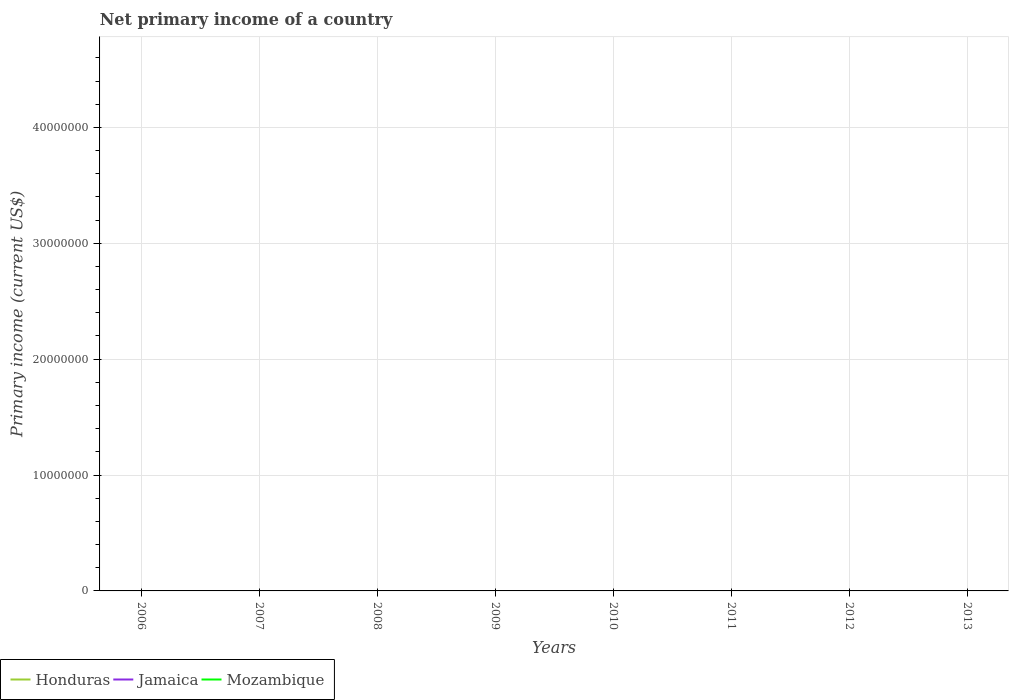Does the line corresponding to Honduras intersect with the line corresponding to Mozambique?
Provide a succinct answer. Yes. Across all years, what is the maximum primary income in Jamaica?
Your response must be concise. 0. What is the difference between the highest and the lowest primary income in Jamaica?
Ensure brevity in your answer.  0. Is the primary income in Mozambique strictly greater than the primary income in Jamaica over the years?
Ensure brevity in your answer.  No. How many legend labels are there?
Offer a very short reply. 3. How are the legend labels stacked?
Ensure brevity in your answer.  Horizontal. What is the title of the graph?
Keep it short and to the point. Net primary income of a country. Does "Uruguay" appear as one of the legend labels in the graph?
Offer a very short reply. No. What is the label or title of the X-axis?
Offer a terse response. Years. What is the label or title of the Y-axis?
Ensure brevity in your answer.  Primary income (current US$). What is the Primary income (current US$) of Jamaica in 2006?
Keep it short and to the point. 0. What is the Primary income (current US$) of Honduras in 2008?
Give a very brief answer. 0. What is the Primary income (current US$) of Jamaica in 2008?
Make the answer very short. 0. What is the Primary income (current US$) of Honduras in 2010?
Make the answer very short. 0. What is the Primary income (current US$) of Honduras in 2011?
Your answer should be compact. 0. What is the Primary income (current US$) of Honduras in 2012?
Give a very brief answer. 0. What is the Primary income (current US$) of Mozambique in 2012?
Your answer should be compact. 0. What is the Primary income (current US$) of Mozambique in 2013?
Ensure brevity in your answer.  0. What is the total Primary income (current US$) in Honduras in the graph?
Ensure brevity in your answer.  0. What is the average Primary income (current US$) of Honduras per year?
Make the answer very short. 0. What is the average Primary income (current US$) of Mozambique per year?
Provide a short and direct response. 0. 